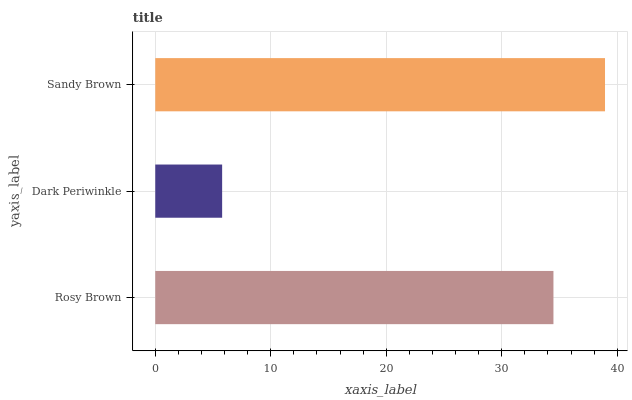Is Dark Periwinkle the minimum?
Answer yes or no. Yes. Is Sandy Brown the maximum?
Answer yes or no. Yes. Is Sandy Brown the minimum?
Answer yes or no. No. Is Dark Periwinkle the maximum?
Answer yes or no. No. Is Sandy Brown greater than Dark Periwinkle?
Answer yes or no. Yes. Is Dark Periwinkle less than Sandy Brown?
Answer yes or no. Yes. Is Dark Periwinkle greater than Sandy Brown?
Answer yes or no. No. Is Sandy Brown less than Dark Periwinkle?
Answer yes or no. No. Is Rosy Brown the high median?
Answer yes or no. Yes. Is Rosy Brown the low median?
Answer yes or no. Yes. Is Dark Periwinkle the high median?
Answer yes or no. No. Is Dark Periwinkle the low median?
Answer yes or no. No. 